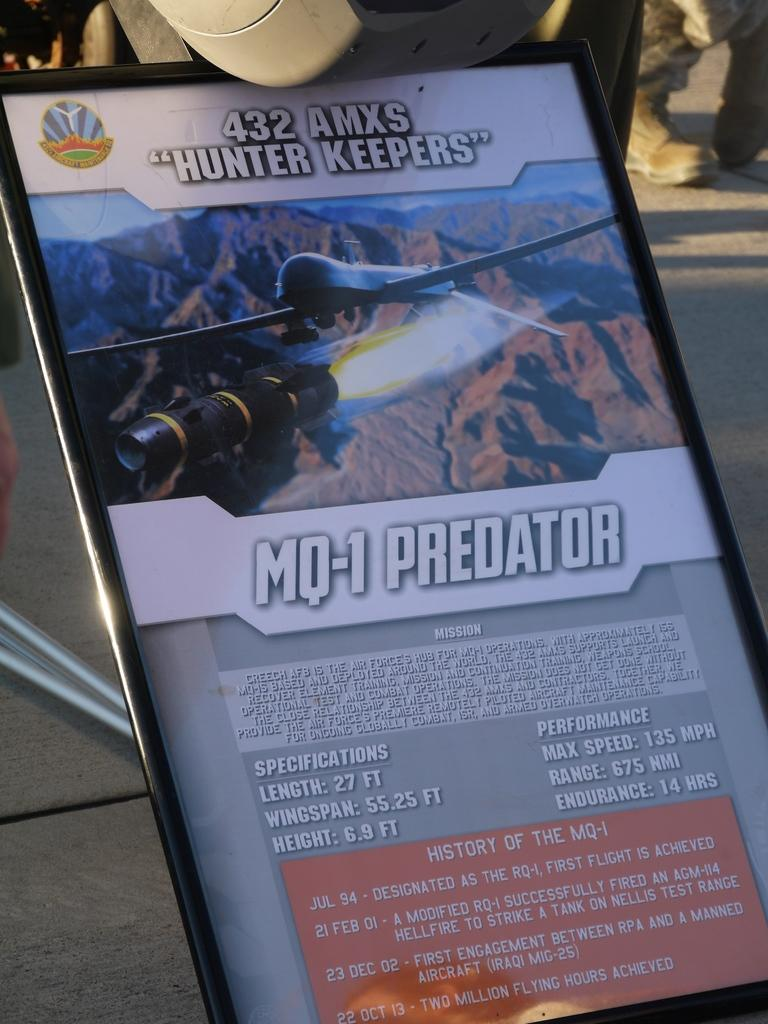<image>
Render a clear and concise summary of the photo. Specifications for the MQ-1 Predator with a wingspan of 55.25 ft. 